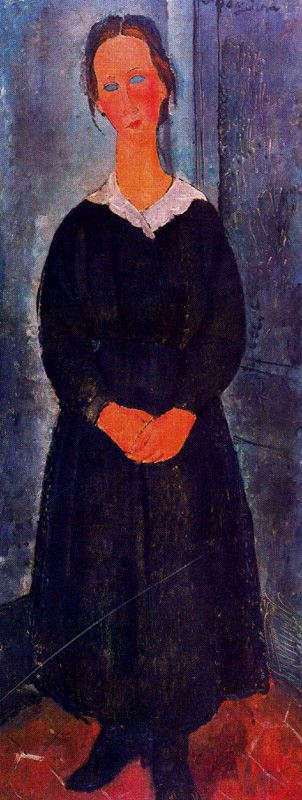Can you discuss the use of lighting in this painting and its effect on the mood? The lighting in the painting is subtle yet effective, casting soft shadows that merge with the blue-gray tones of the background. This use of lighting enhances the sense of solitude and contemplation, creating a mood that is both quiet and introspective. The gentle illumination on the woman’s face and dress highlights her as the focal point, while also adding a layer of depth to the emotional atmosphere of the scene. 